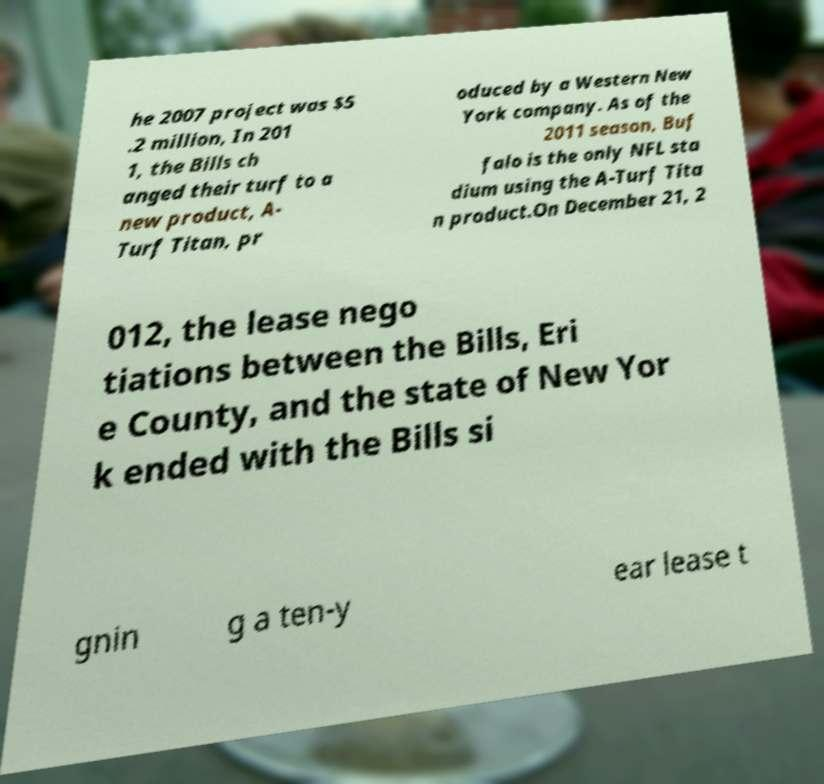Can you accurately transcribe the text from the provided image for me? he 2007 project was $5 .2 million, In 201 1, the Bills ch anged their turf to a new product, A- Turf Titan, pr oduced by a Western New York company. As of the 2011 season, Buf falo is the only NFL sta dium using the A-Turf Tita n product.On December 21, 2 012, the lease nego tiations between the Bills, Eri e County, and the state of New Yor k ended with the Bills si gnin g a ten-y ear lease t 